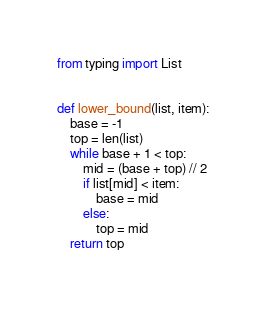Convert code to text. <code><loc_0><loc_0><loc_500><loc_500><_Python_>from typing import List


def lower_bound(list, item):
    base = -1
    top = len(list)
    while base + 1 < top:
        mid = (base + top) // 2
        if list[mid] < item:
            base = mid
        else:
            top = mid
    return top
</code> 